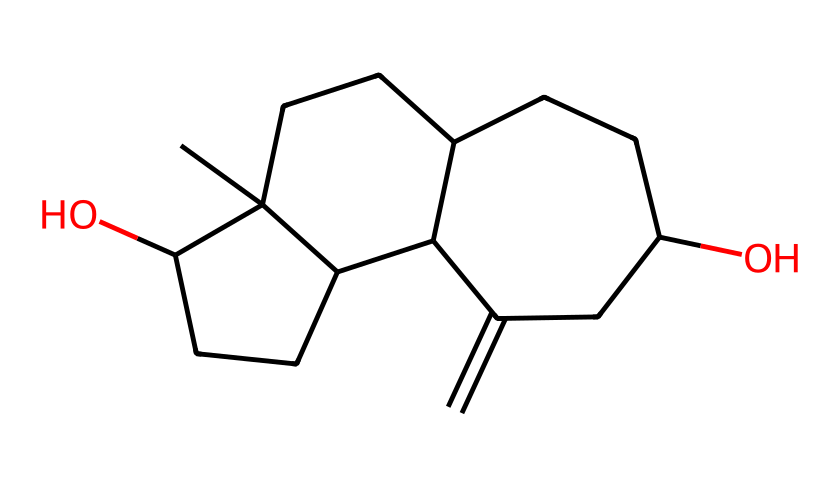How many carbon atoms are in the chemical structure of estrogen? Count the number of carbon atoms (C) present in the SMILES representation. In this structure, there are a total of 15 carbon atoms.
Answer: 15 What are the functional groups present in this chemical structure? Analyze the structure to identify functional groups like hydroxyl (-OH) and any other distinguishing features. In this case, there are hydroxyl groups present as indicated by the 'O' connected to other parts of the structure.
Answer: hydroxyl groups What is the molecular formula of this estrogen compound? To derive the molecular formula from the SMILES representation, count the number of each type of atom: 15 carbon (C), 20 hydrogen (H), and 2 oxygen (O), giving the formula C15H20O2.
Answer: C15H20O2 Which part of this chemical structure indicates it is a steroid? Identify the characteristic cyclic structure present in estrogens. The multiple fused rings (indicated by the CCC and C symbols in the SMILES) are indicative of a steroid structure.
Answer: fused cyclic rings How many hydroxyl (-OH) groups are present in this structure? Examine the structure for -OH functional groups specifically. There are two -OH groups (indicated by the 'O' in the structure) that are characteristic of estrogen.
Answer: 2 What type of interaction would the hydroxyl groups promote in estrogen? Consider the nature of hydroxyl groups, which are polar and capable of forming hydrogen bonds. This would promote interactions with other polar molecules such as water or proteins.
Answer: hydrogen bonding What role does estrogen play in the human body? Reflect on the known biological function of estrogen in women's health, including its role in regulating reproductive processes and influencing various physiological functions.
Answer: reproductive hormone 